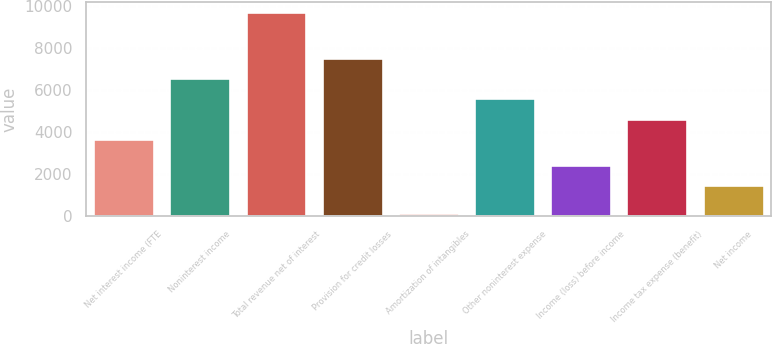Convert chart. <chart><loc_0><loc_0><loc_500><loc_500><bar_chart><fcel>Net interest income (FTE<fcel>Noninterest income<fcel>Total revenue net of interest<fcel>Provision for credit losses<fcel>Amortization of intangibles<fcel>Other noninterest expense<fcel>Income (loss) before income<fcel>Income tax expense (benefit)<fcel>Net income<nl><fcel>3656<fcel>6550.7<fcel>9695<fcel>7502.4<fcel>178<fcel>5599<fcel>2423.7<fcel>4607.7<fcel>1472<nl></chart> 